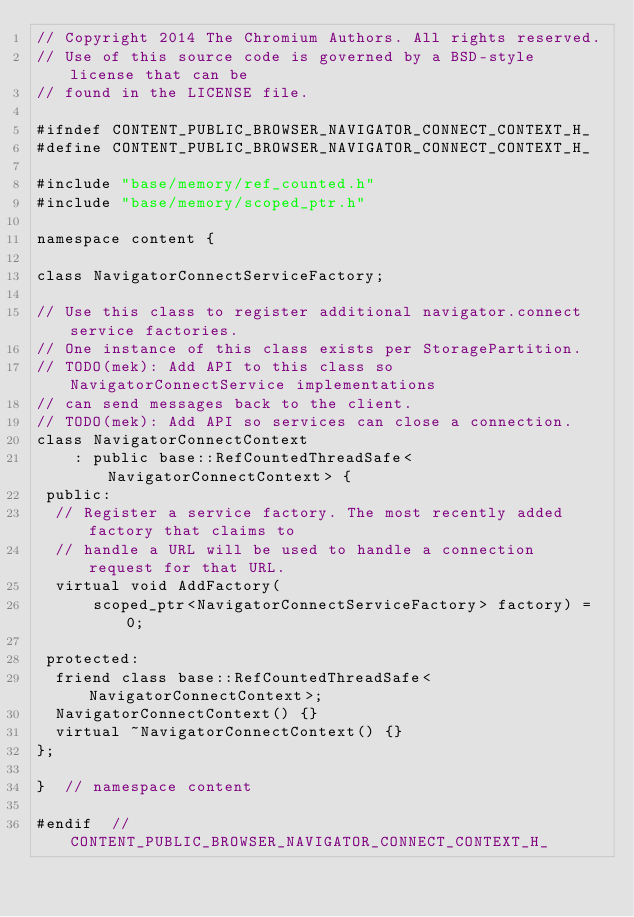<code> <loc_0><loc_0><loc_500><loc_500><_C_>// Copyright 2014 The Chromium Authors. All rights reserved.
// Use of this source code is governed by a BSD-style license that can be
// found in the LICENSE file.

#ifndef CONTENT_PUBLIC_BROWSER_NAVIGATOR_CONNECT_CONTEXT_H_
#define CONTENT_PUBLIC_BROWSER_NAVIGATOR_CONNECT_CONTEXT_H_

#include "base/memory/ref_counted.h"
#include "base/memory/scoped_ptr.h"

namespace content {

class NavigatorConnectServiceFactory;

// Use this class to register additional navigator.connect service factories.
// One instance of this class exists per StoragePartition.
// TODO(mek): Add API to this class so NavigatorConnectService implementations
// can send messages back to the client.
// TODO(mek): Add API so services can close a connection.
class NavigatorConnectContext
    : public base::RefCountedThreadSafe<NavigatorConnectContext> {
 public:
  // Register a service factory. The most recently added factory that claims to
  // handle a URL will be used to handle a connection request for that URL.
  virtual void AddFactory(
      scoped_ptr<NavigatorConnectServiceFactory> factory) = 0;

 protected:
  friend class base::RefCountedThreadSafe<NavigatorConnectContext>;
  NavigatorConnectContext() {}
  virtual ~NavigatorConnectContext() {}
};

}  // namespace content

#endif  // CONTENT_PUBLIC_BROWSER_NAVIGATOR_CONNECT_CONTEXT_H_
</code> 